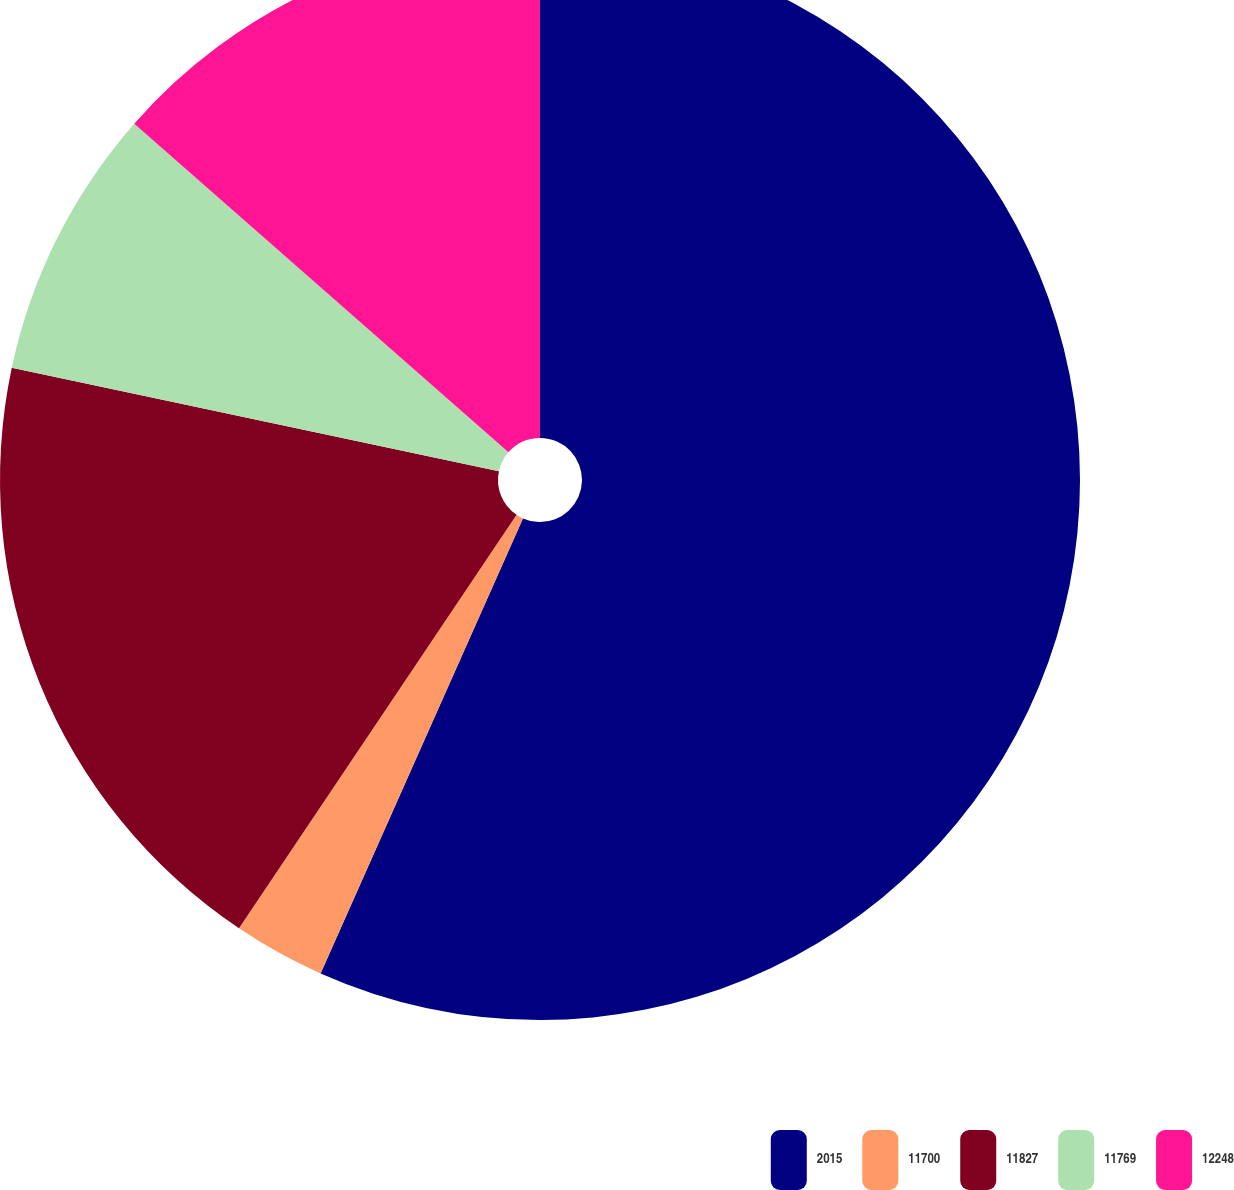<chart> <loc_0><loc_0><loc_500><loc_500><pie_chart><fcel>2015<fcel>11700<fcel>11827<fcel>11769<fcel>12248<nl><fcel>56.66%<fcel>2.75%<fcel>18.92%<fcel>8.14%<fcel>13.53%<nl></chart> 